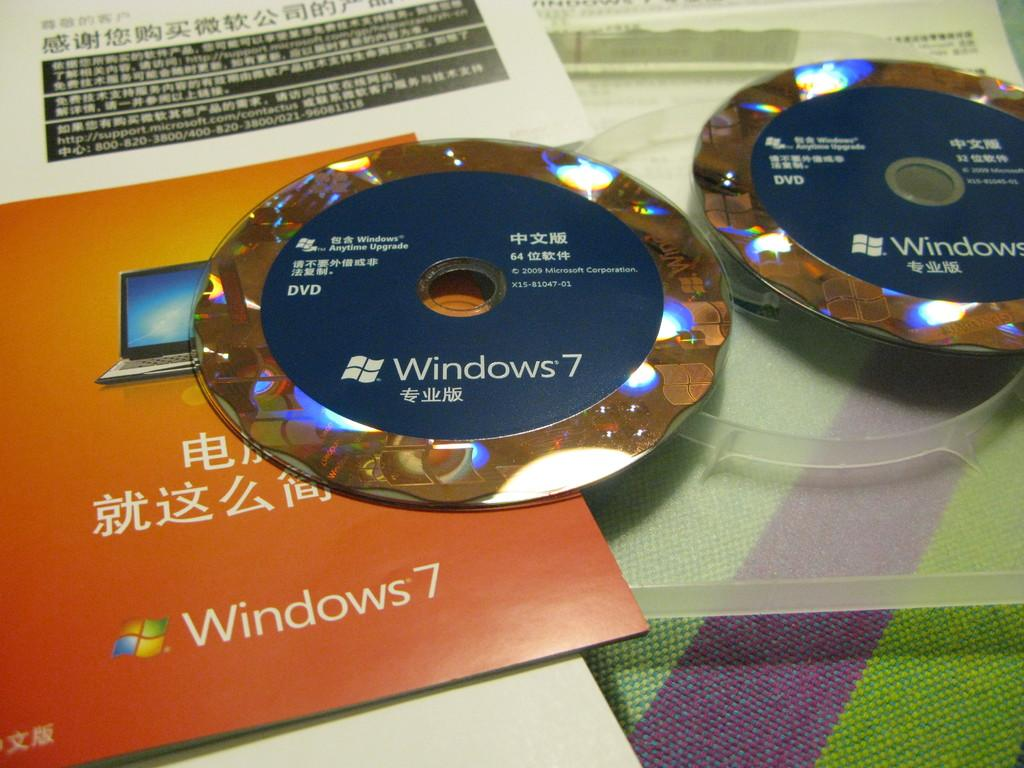<image>
Share a concise interpretation of the image provided. two different discs sitting next to one another that say 'windows 7' 